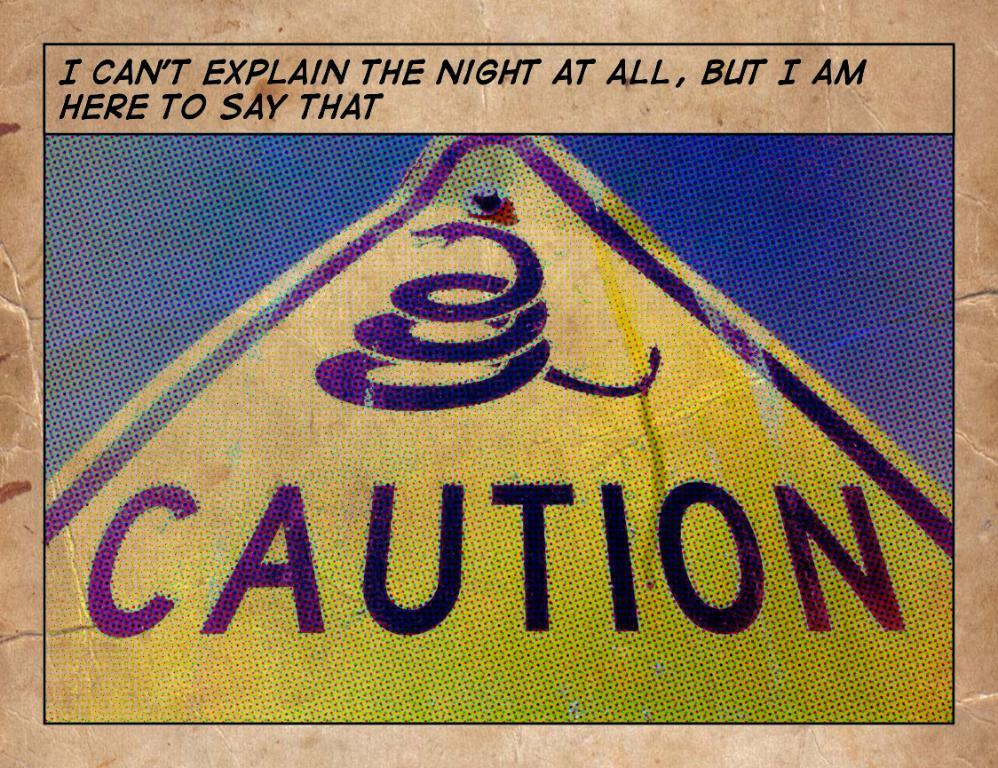<image>
Write a terse but informative summary of the picture. A poster reading Caution in the middle of a triangle. 